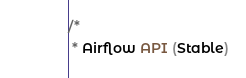Convert code to text. <code><loc_0><loc_0><loc_500><loc_500><_Java_>/*
 * Airflow API (Stable)</code> 